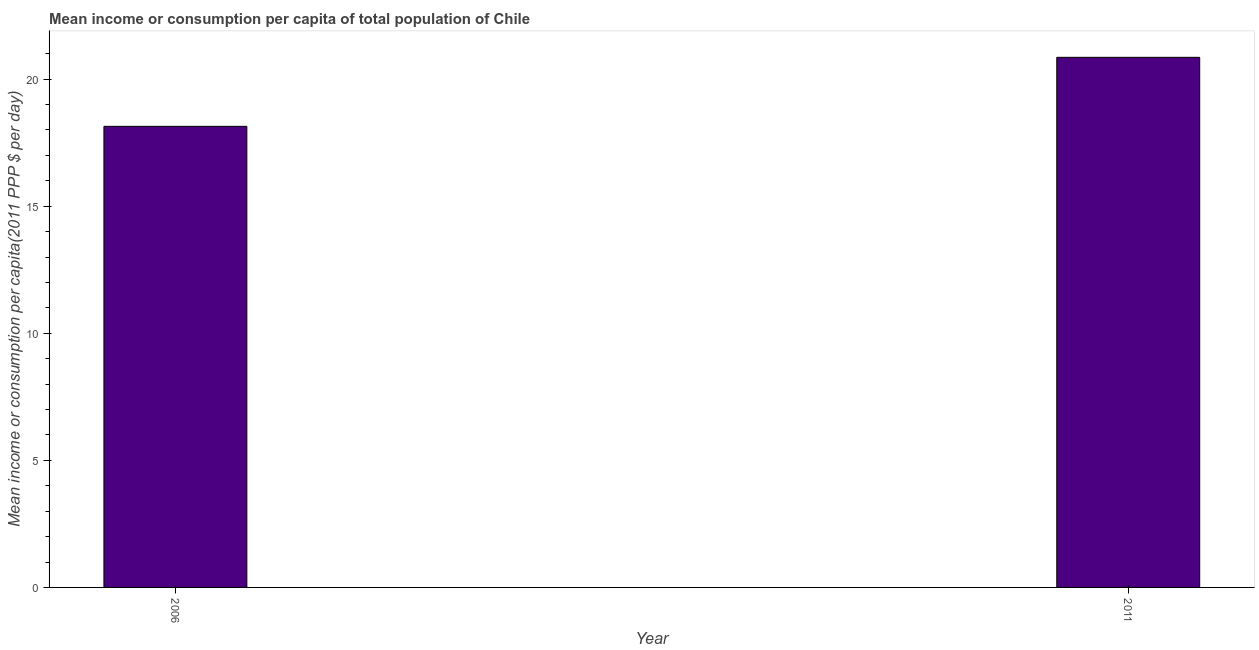Does the graph contain any zero values?
Give a very brief answer. No. What is the title of the graph?
Your answer should be very brief. Mean income or consumption per capita of total population of Chile. What is the label or title of the X-axis?
Give a very brief answer. Year. What is the label or title of the Y-axis?
Provide a succinct answer. Mean income or consumption per capita(2011 PPP $ per day). What is the mean income or consumption in 2006?
Offer a very short reply. 18.14. Across all years, what is the maximum mean income or consumption?
Make the answer very short. 20.86. Across all years, what is the minimum mean income or consumption?
Your answer should be very brief. 18.14. What is the sum of the mean income or consumption?
Provide a short and direct response. 39. What is the difference between the mean income or consumption in 2006 and 2011?
Your answer should be very brief. -2.71. What is the average mean income or consumption per year?
Your answer should be very brief. 19.5. What is the median mean income or consumption?
Ensure brevity in your answer.  19.5. What is the ratio of the mean income or consumption in 2006 to that in 2011?
Make the answer very short. 0.87. How many years are there in the graph?
Ensure brevity in your answer.  2. Are the values on the major ticks of Y-axis written in scientific E-notation?
Your answer should be compact. No. What is the Mean income or consumption per capita(2011 PPP $ per day) in 2006?
Provide a short and direct response. 18.14. What is the Mean income or consumption per capita(2011 PPP $ per day) of 2011?
Your answer should be compact. 20.86. What is the difference between the Mean income or consumption per capita(2011 PPP $ per day) in 2006 and 2011?
Keep it short and to the point. -2.71. What is the ratio of the Mean income or consumption per capita(2011 PPP $ per day) in 2006 to that in 2011?
Your response must be concise. 0.87. 